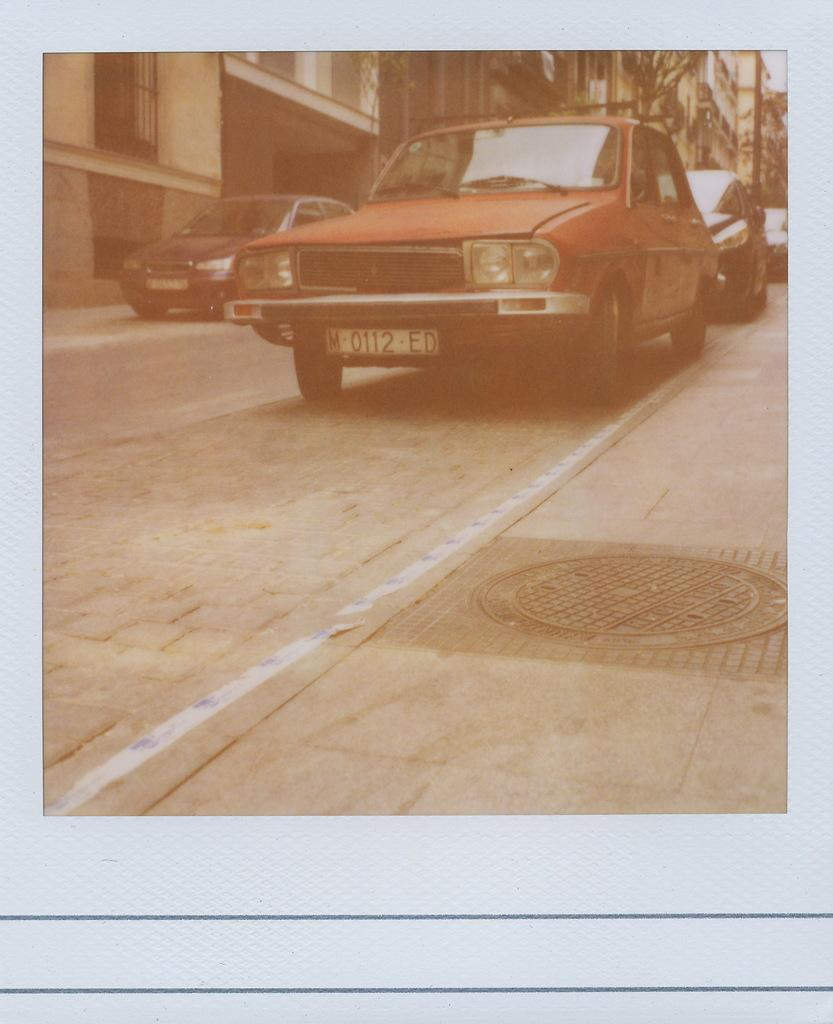What type of vehicles can be seen in the image? There are cars in the image. What structures are present in the image? There are buildings in the image. What type of string can be seen connecting the buildings in the image? There is no string connecting the buildings in the image. What is the temperature like in the image? The temperature or heat level cannot be determined from the image. 